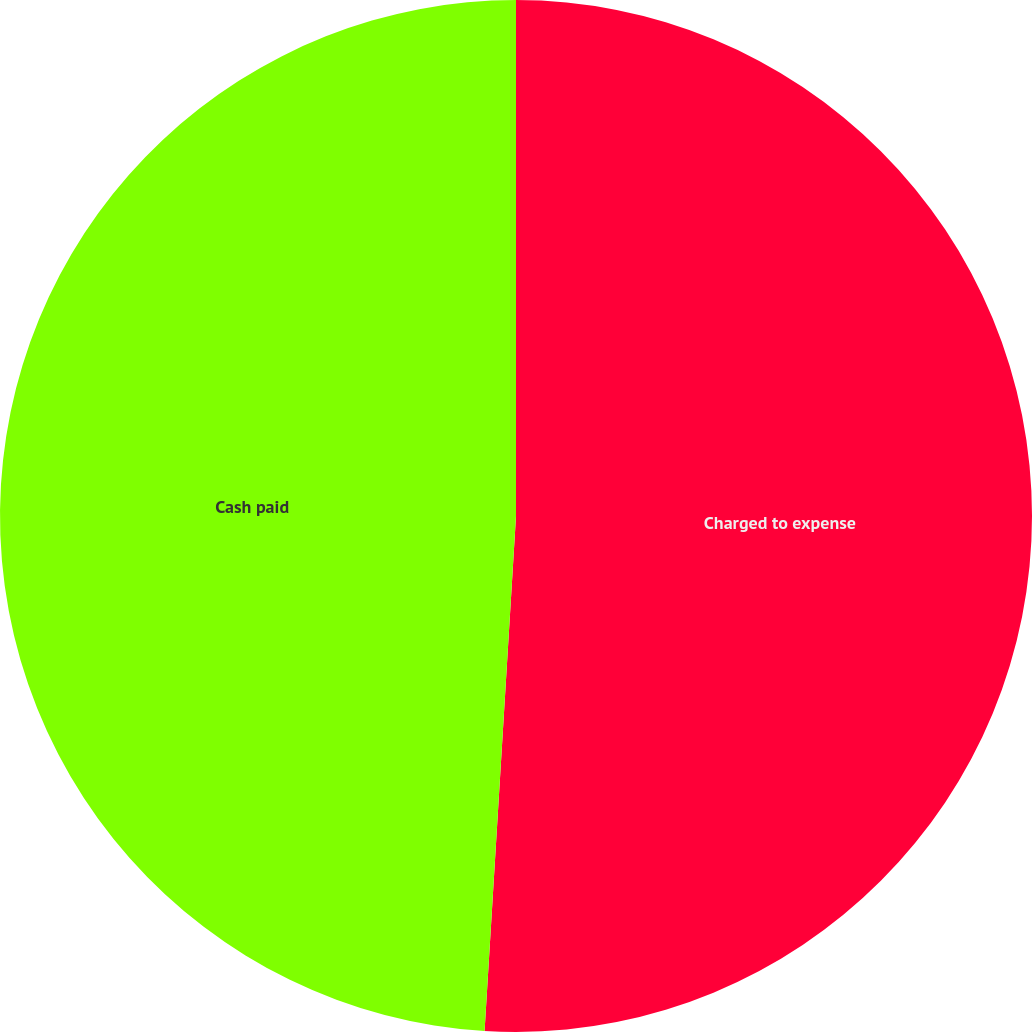Convert chart. <chart><loc_0><loc_0><loc_500><loc_500><pie_chart><fcel>Charged to expense<fcel>Cash paid<nl><fcel>50.97%<fcel>49.03%<nl></chart> 